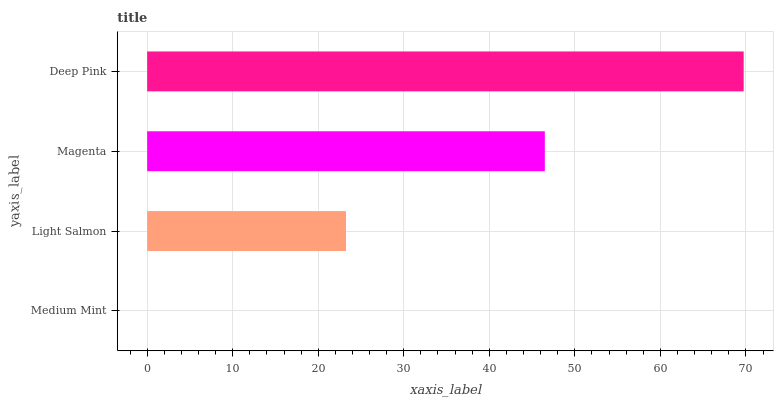Is Medium Mint the minimum?
Answer yes or no. Yes. Is Deep Pink the maximum?
Answer yes or no. Yes. Is Light Salmon the minimum?
Answer yes or no. No. Is Light Salmon the maximum?
Answer yes or no. No. Is Light Salmon greater than Medium Mint?
Answer yes or no. Yes. Is Medium Mint less than Light Salmon?
Answer yes or no. Yes. Is Medium Mint greater than Light Salmon?
Answer yes or no. No. Is Light Salmon less than Medium Mint?
Answer yes or no. No. Is Magenta the high median?
Answer yes or no. Yes. Is Light Salmon the low median?
Answer yes or no. Yes. Is Deep Pink the high median?
Answer yes or no. No. Is Medium Mint the low median?
Answer yes or no. No. 